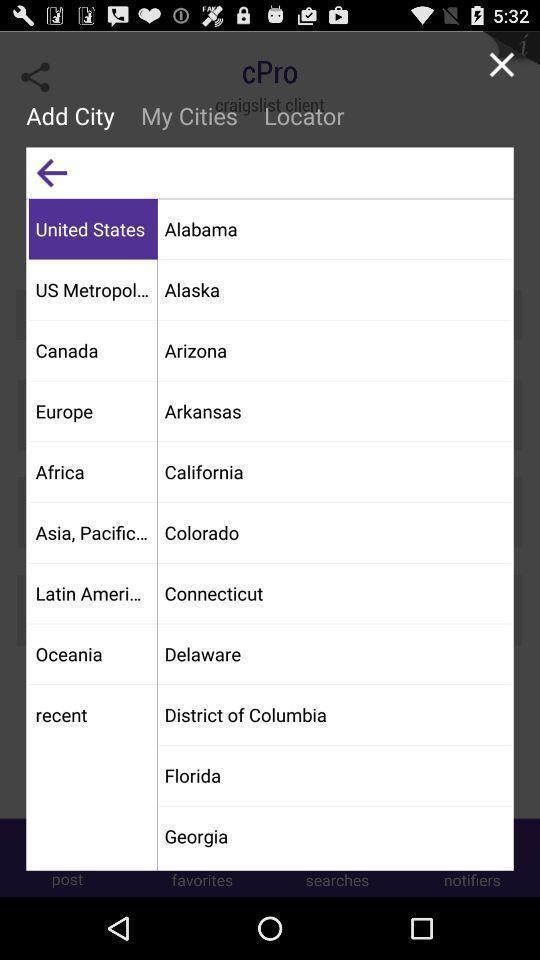Tell me about the visual elements in this screen capture. Popup to add from the list of options. 